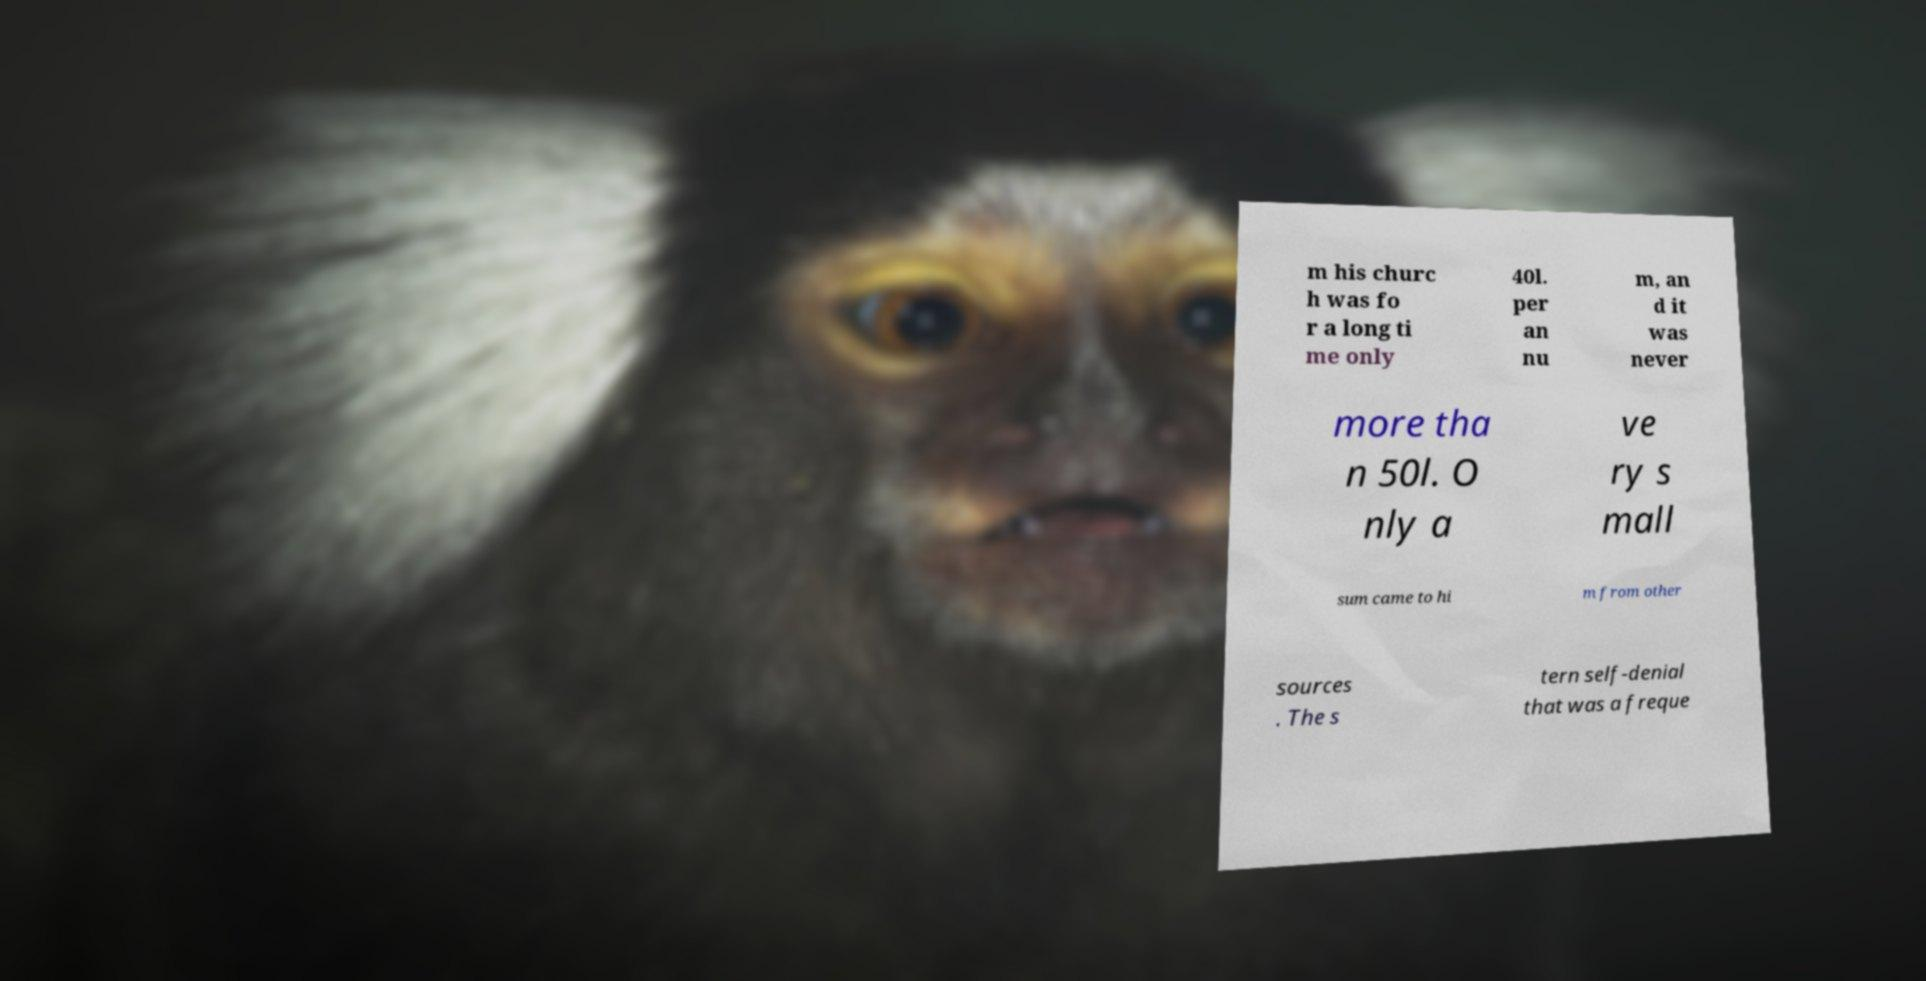For documentation purposes, I need the text within this image transcribed. Could you provide that? m his churc h was fo r a long ti me only 40l. per an nu m, an d it was never more tha n 50l. O nly a ve ry s mall sum came to hi m from other sources . The s tern self-denial that was a freque 